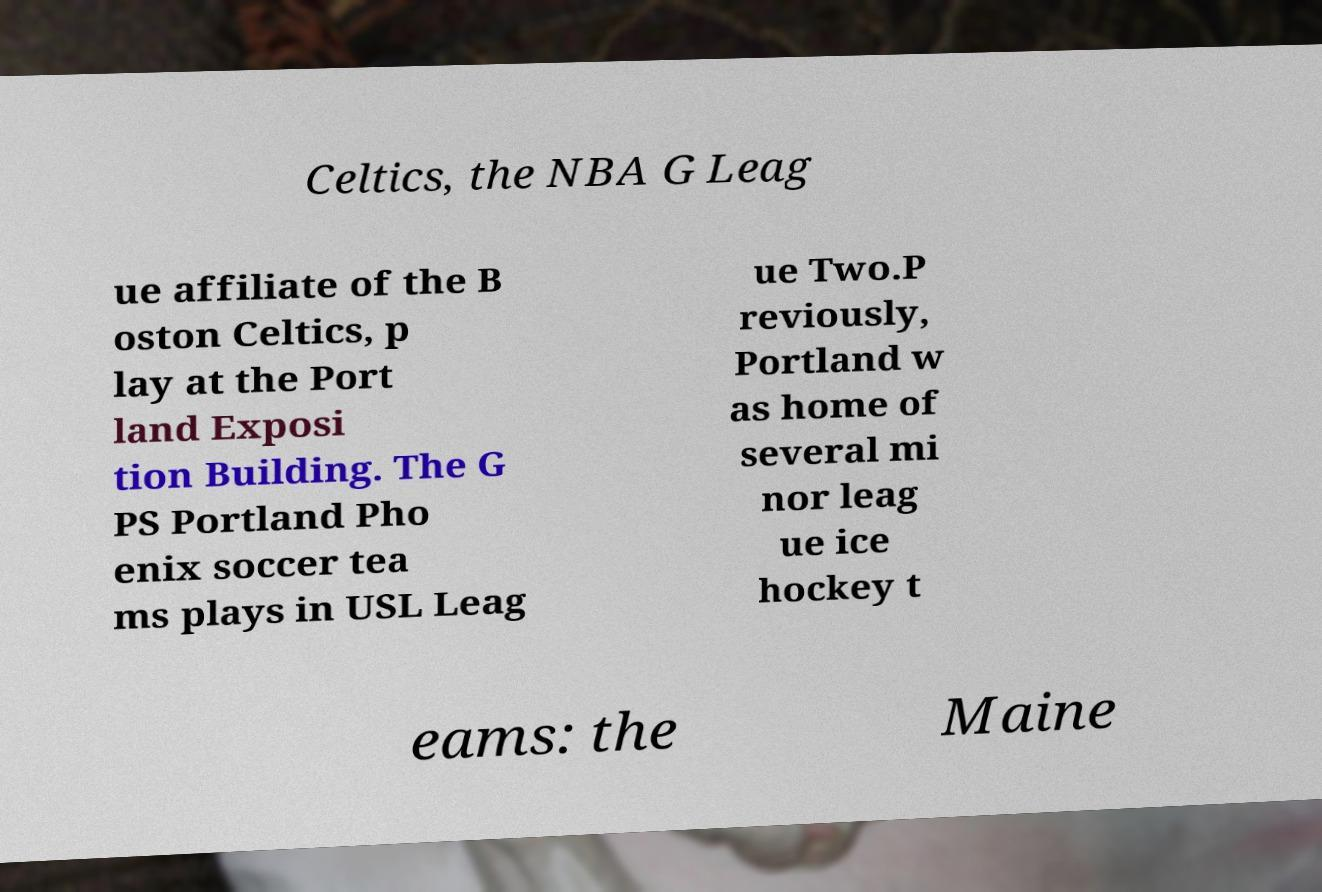Can you read and provide the text displayed in the image?This photo seems to have some interesting text. Can you extract and type it out for me? Celtics, the NBA G Leag ue affiliate of the B oston Celtics, p lay at the Port land Exposi tion Building. The G PS Portland Pho enix soccer tea ms plays in USL Leag ue Two.P reviously, Portland w as home of several mi nor leag ue ice hockey t eams: the Maine 